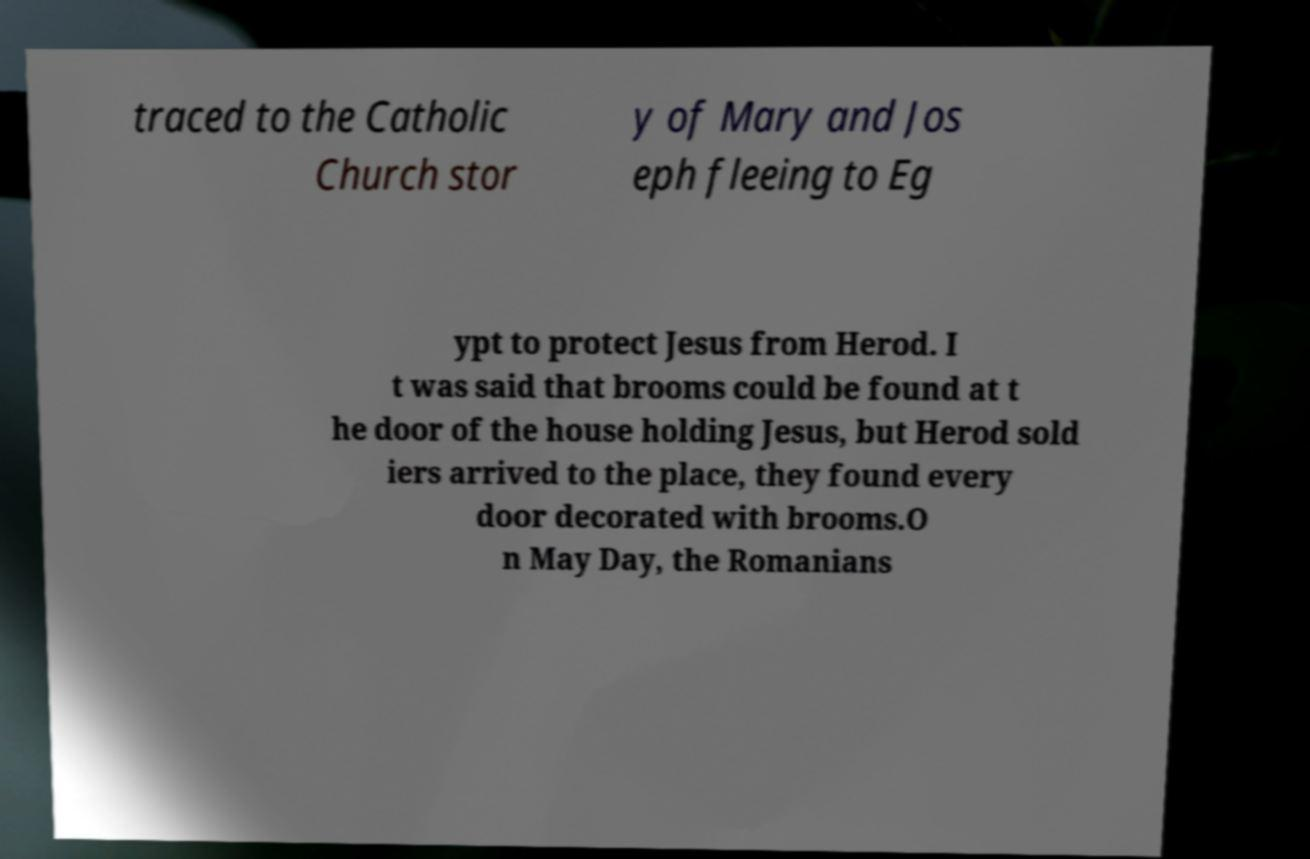For documentation purposes, I need the text within this image transcribed. Could you provide that? traced to the Catholic Church stor y of Mary and Jos eph fleeing to Eg ypt to protect Jesus from Herod. I t was said that brooms could be found at t he door of the house holding Jesus, but Herod sold iers arrived to the place, they found every door decorated with brooms.O n May Day, the Romanians 